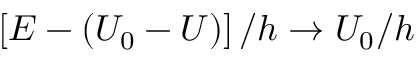<formula> <loc_0><loc_0><loc_500><loc_500>\left [ E - ( U _ { 0 } - U ) \right ] / h \to U _ { 0 } / h</formula> 